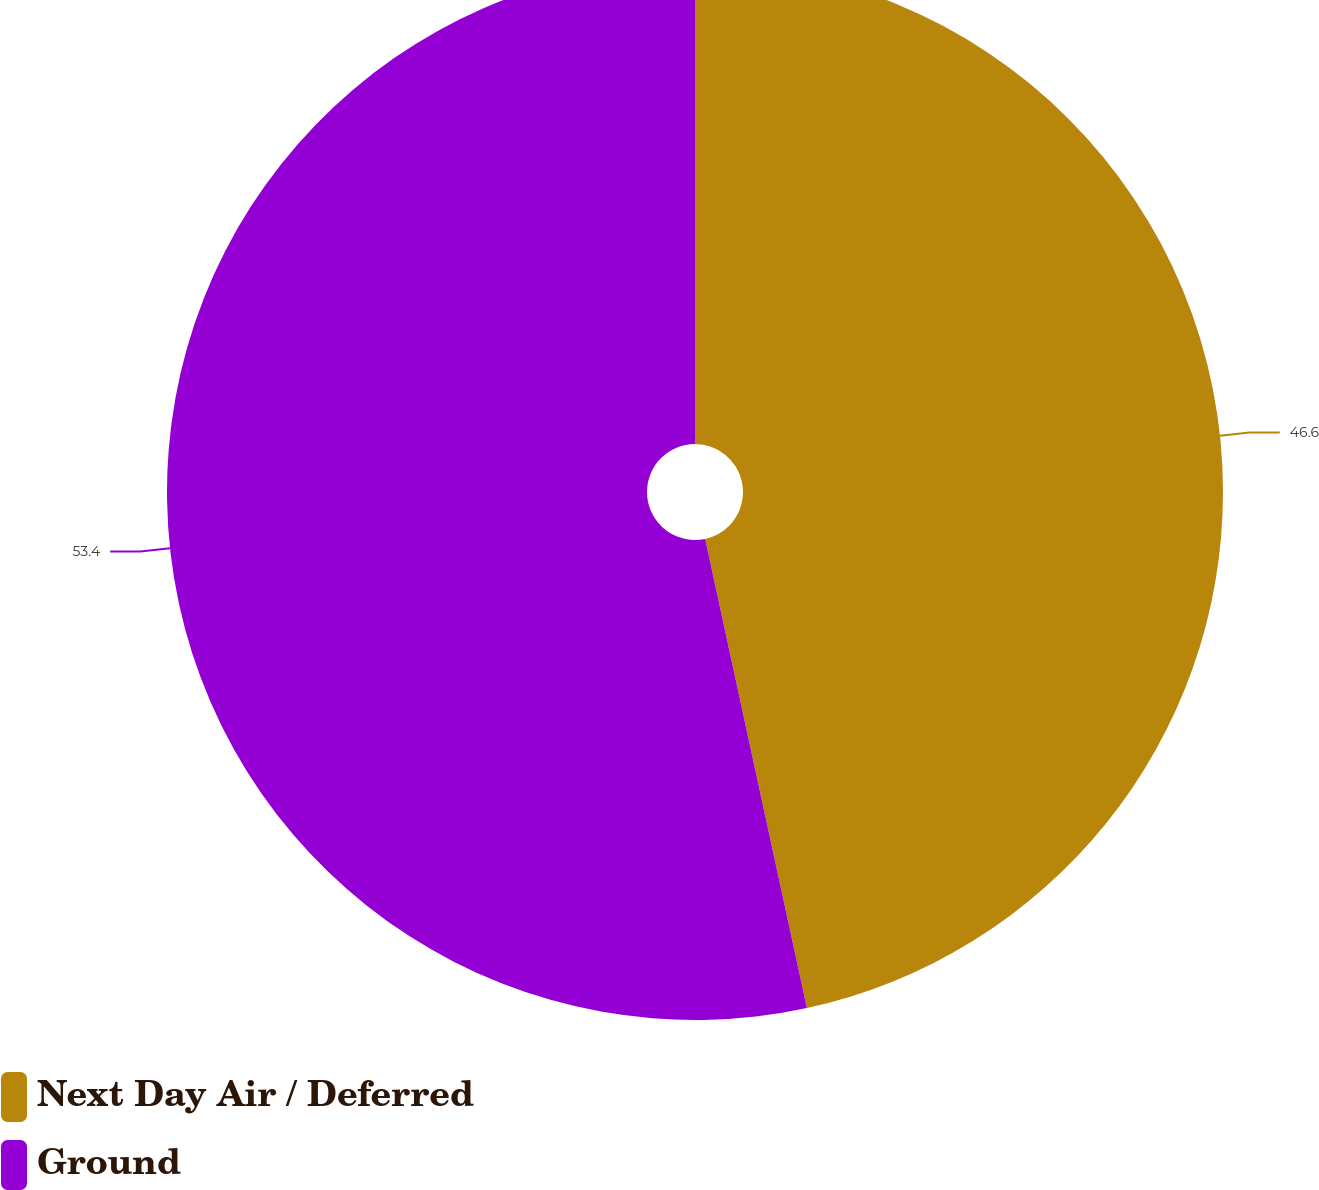Convert chart. <chart><loc_0><loc_0><loc_500><loc_500><pie_chart><fcel>Next Day Air / Deferred<fcel>Ground<nl><fcel>46.6%<fcel>53.4%<nl></chart> 